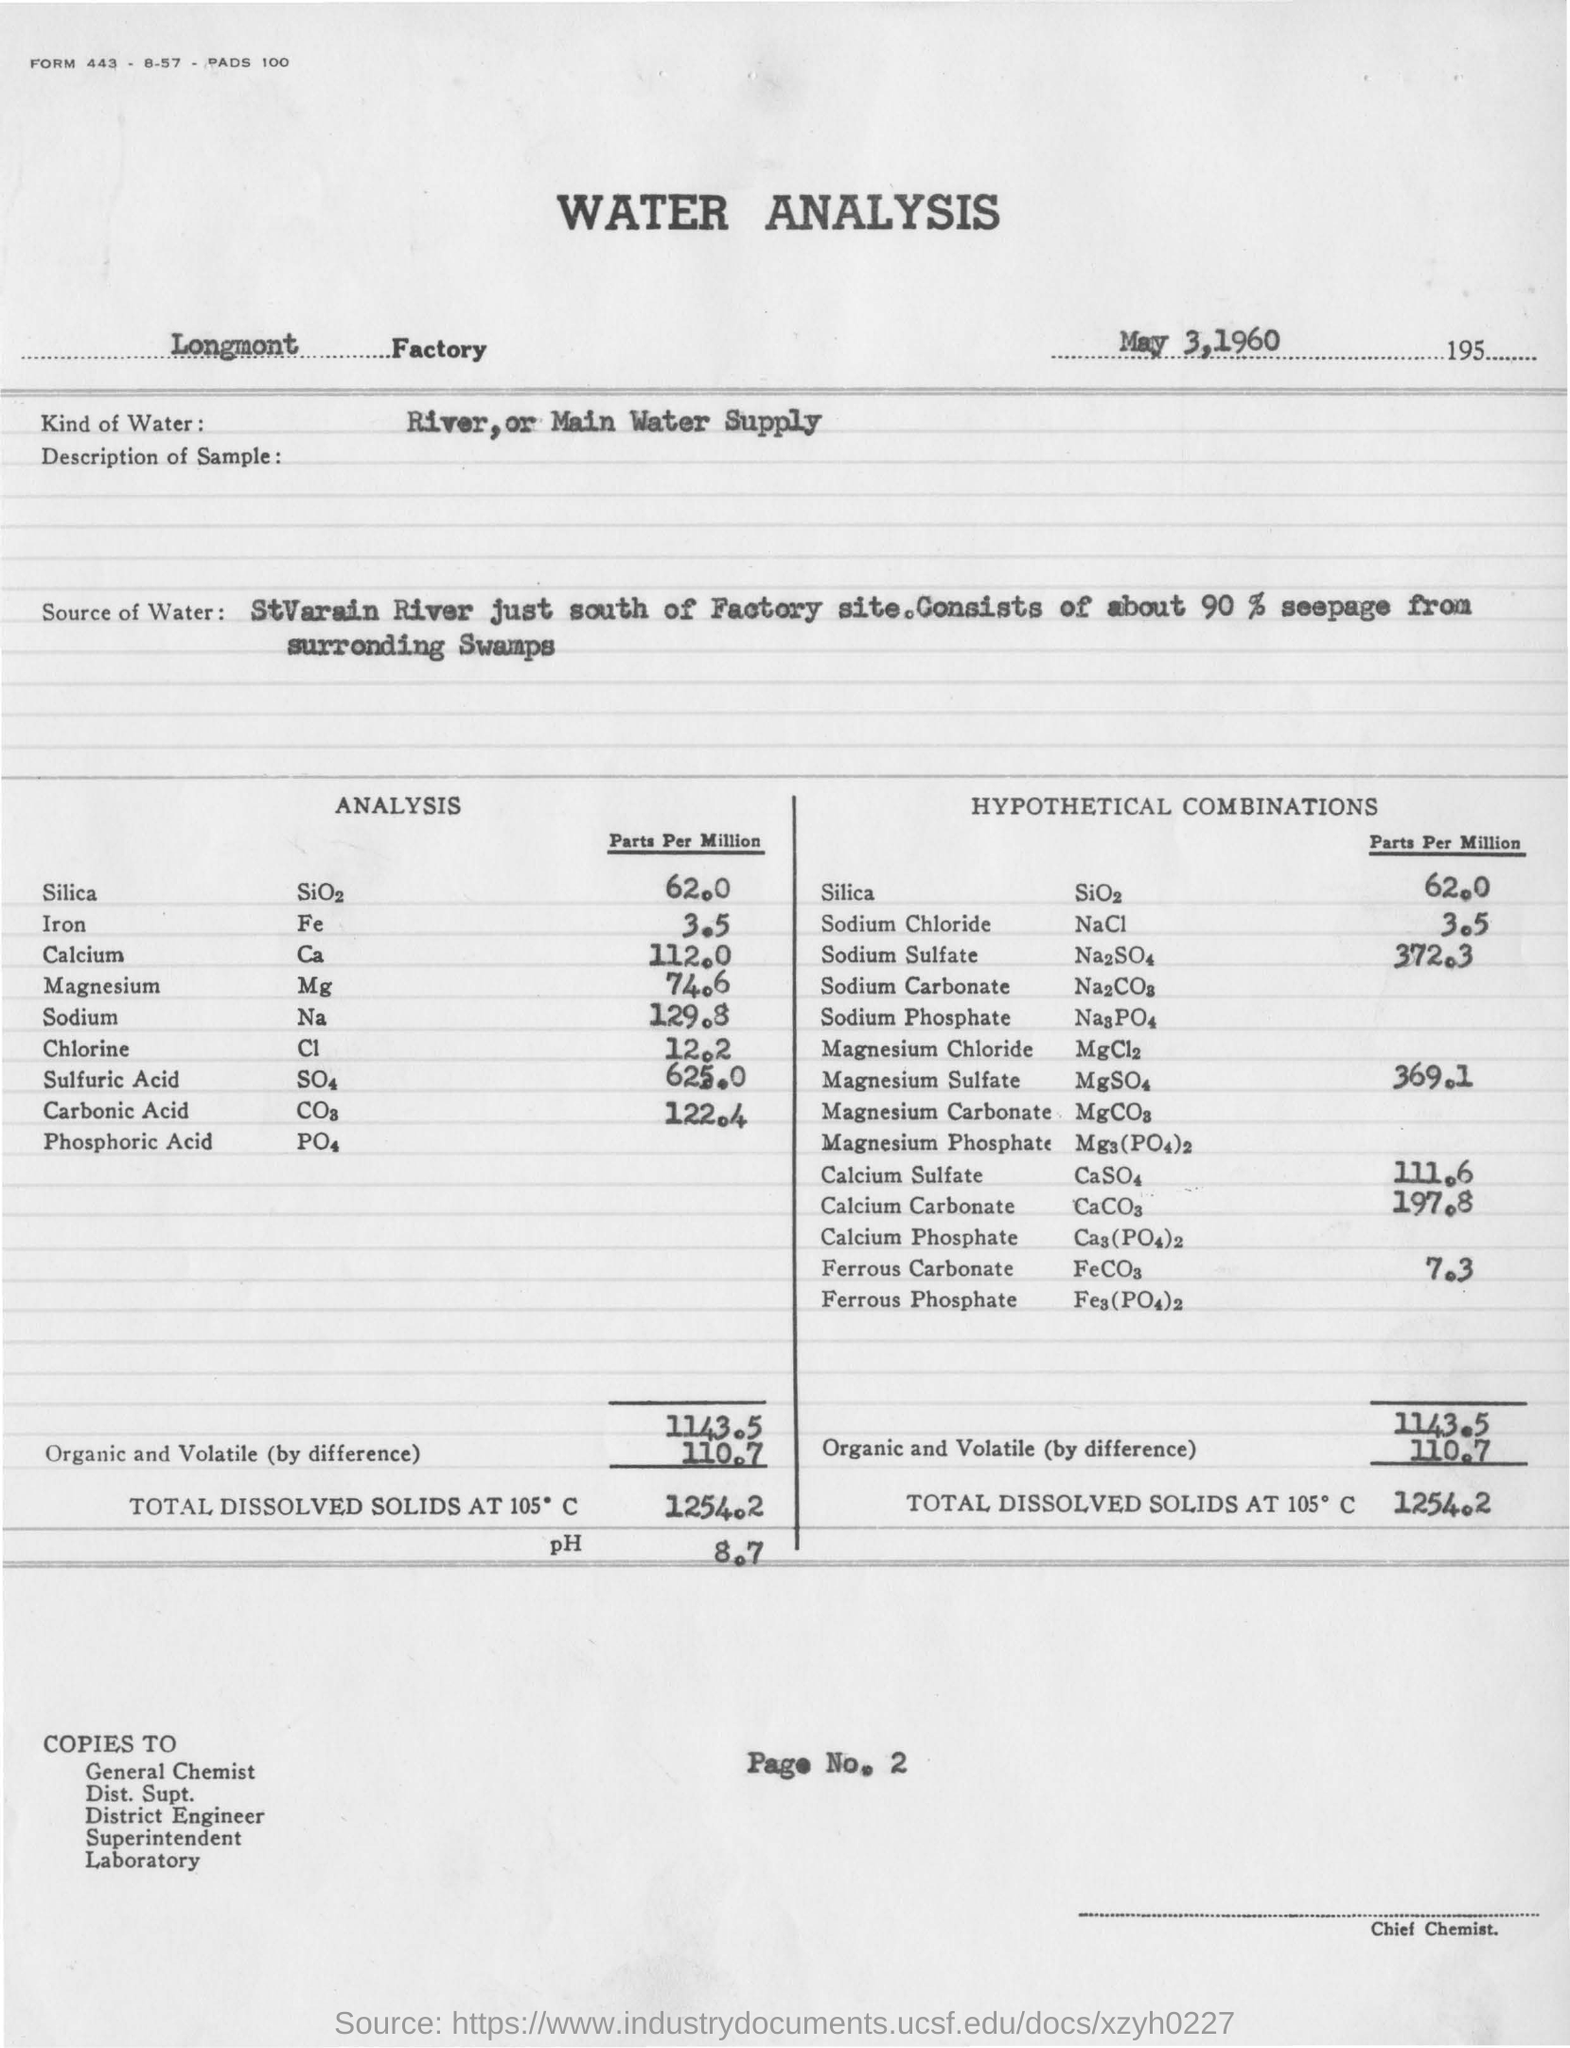What  kind of water was used in the analysis?
Make the answer very short. River, or Main Water Supply. Which factory is mentioned in the report?
Your answer should be compact. Longmont Factory. What is the pH mentioned?
Make the answer very short. 8.7. When did the analysis take place?
Offer a terse response. May 3,1960. 